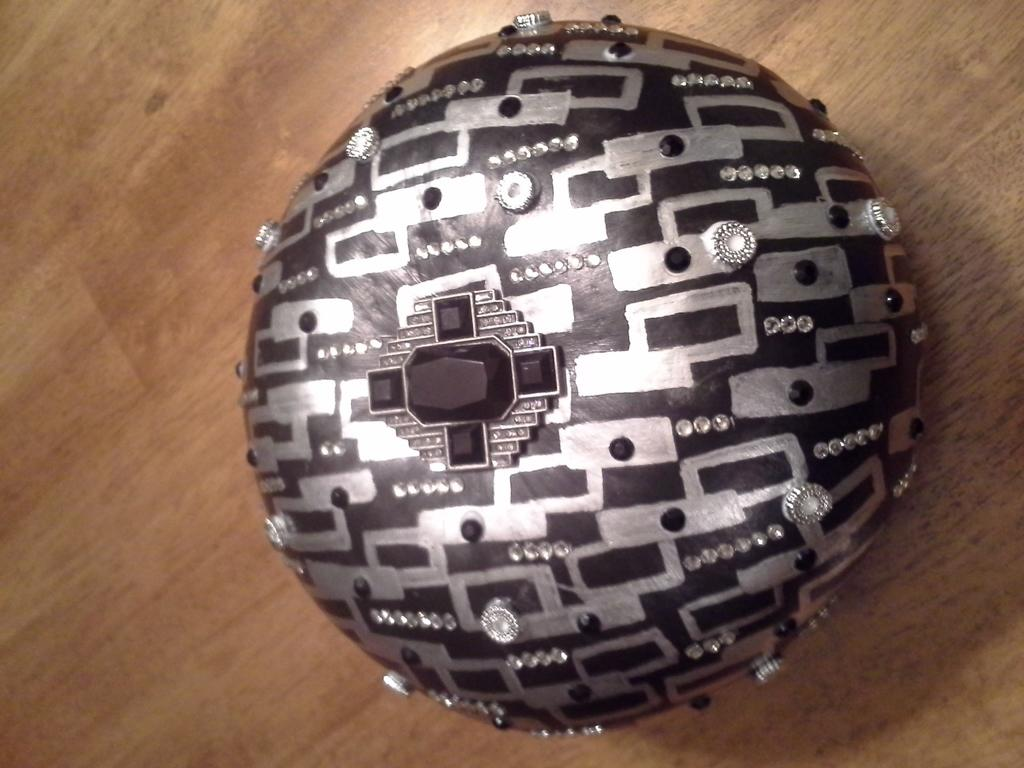What is the main subject of the image? There is an object in the image. What is the color of the surface on which the object is placed? The object is on a brown surface. What colors can be seen on the object itself? The object has black and silver colors. What type of material is present on the object? There are stones on the object. What type of meat can be seen on the object in the image? There is no meat present on the object in the image. How does the object taste in the image? The image does not provide any information about the taste of the object. 